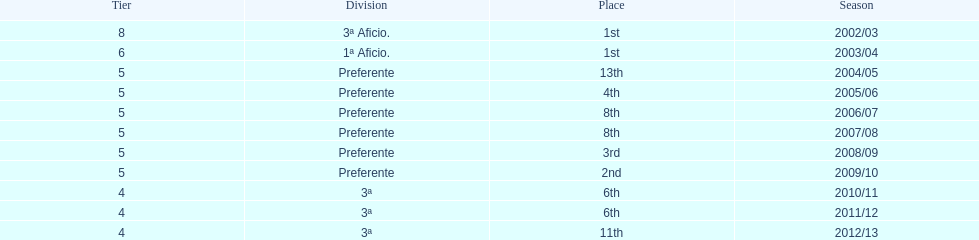Can you give me this table as a dict? {'header': ['Tier', 'Division', 'Place', 'Season'], 'rows': [['8', '3ª Aficio.', '1st', '2002/03'], ['6', '1ª Aficio.', '1st', '2003/04'], ['5', 'Preferente', '13th', '2004/05'], ['5', 'Preferente', '4th', '2005/06'], ['5', 'Preferente', '8th', '2006/07'], ['5', 'Preferente', '8th', '2007/08'], ['5', 'Preferente', '3rd', '2008/09'], ['5', 'Preferente', '2nd', '2009/10'], ['4', '3ª', '6th', '2010/11'], ['4', '3ª', '6th', '2011/12'], ['4', '3ª', '11th', '2012/13']]} What place was 1a aficio and 3a aficio? 1st. 